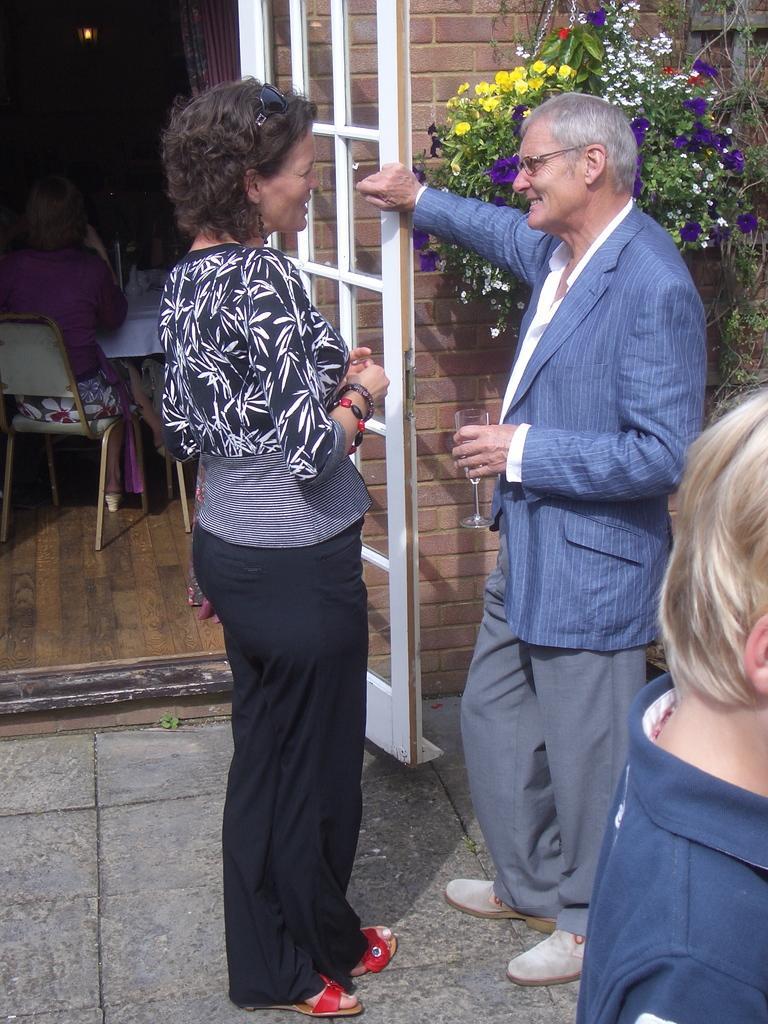Could you give a brief overview of what you see in this image? In this image, we can see persons wearing clothes. There is a person on the left side of the image sitting on the chair in front of the table. There is a door and wall in the middle of the image. There are plants in the top right of the image. There is a person in the right side of the image holding a glass with his hand. 